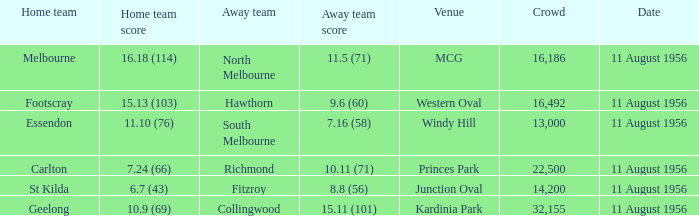What is the home team score for Footscray? 15.13 (103). 